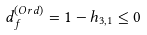<formula> <loc_0><loc_0><loc_500><loc_500>d ^ { ( O r d ) } _ { f } = 1 - h _ { 3 , 1 } \leq 0</formula> 